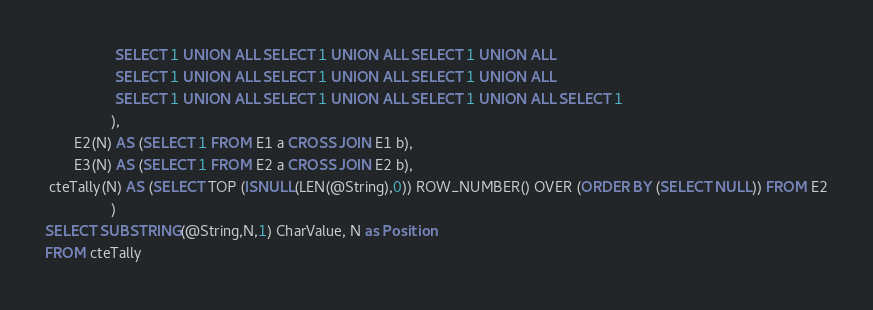Convert code to text. <code><loc_0><loc_0><loc_500><loc_500><_SQL_>                 SELECT 1 UNION ALL SELECT 1 UNION ALL SELECT 1 UNION ALL
                 SELECT 1 UNION ALL SELECT 1 UNION ALL SELECT 1 UNION ALL
                 SELECT 1 UNION ALL SELECT 1 UNION ALL SELECT 1 UNION ALL SELECT 1
                ),                                    
       E2(N) AS (SELECT 1 FROM E1 a CROSS JOIN E1 b), 
       E3(N) AS (SELECT 1 FROM E2 a CROSS JOIN E2 b), 
 cteTally(N) AS (SELECT TOP (ISNULL(LEN(@String),0)) ROW_NUMBER() OVER (ORDER BY (SELECT NULL)) FROM E2
                )
SELECT SUBSTRING(@String,N,1) CharValue, N as Position
FROM cteTally</code> 